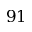Convert formula to latex. <formula><loc_0><loc_0><loc_500><loc_500>9 1</formula> 